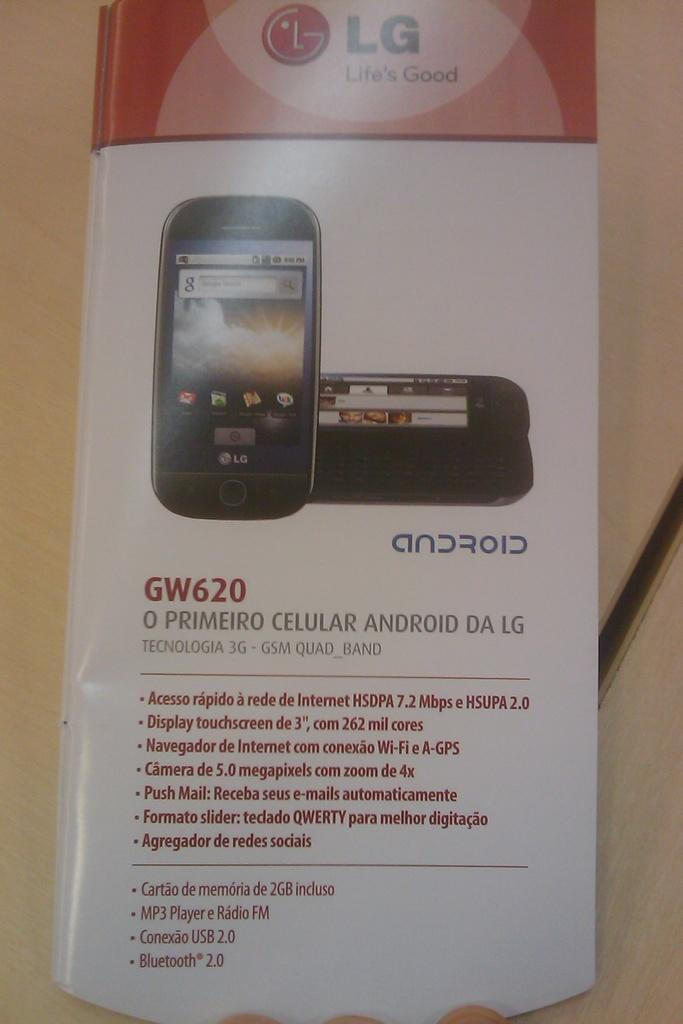<image>
Give a short and clear explanation of the subsequent image. An LG brochure has information about the GW620 on it. 